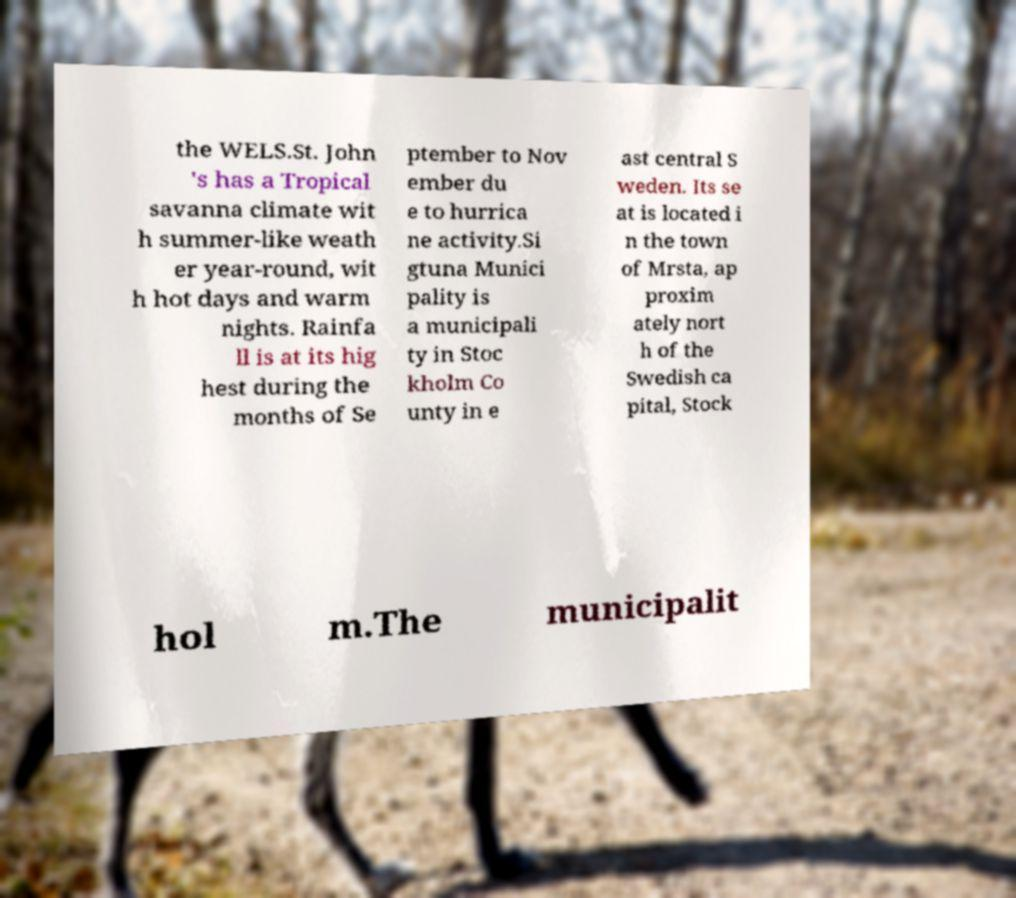Can you read and provide the text displayed in the image?This photo seems to have some interesting text. Can you extract and type it out for me? the WELS.St. John 's has a Tropical savanna climate wit h summer-like weath er year-round, wit h hot days and warm nights. Rainfa ll is at its hig hest during the months of Se ptember to Nov ember du e to hurrica ne activity.Si gtuna Munici pality is a municipali ty in Stoc kholm Co unty in e ast central S weden. Its se at is located i n the town of Mrsta, ap proxim ately nort h of the Swedish ca pital, Stock hol m.The municipalit 